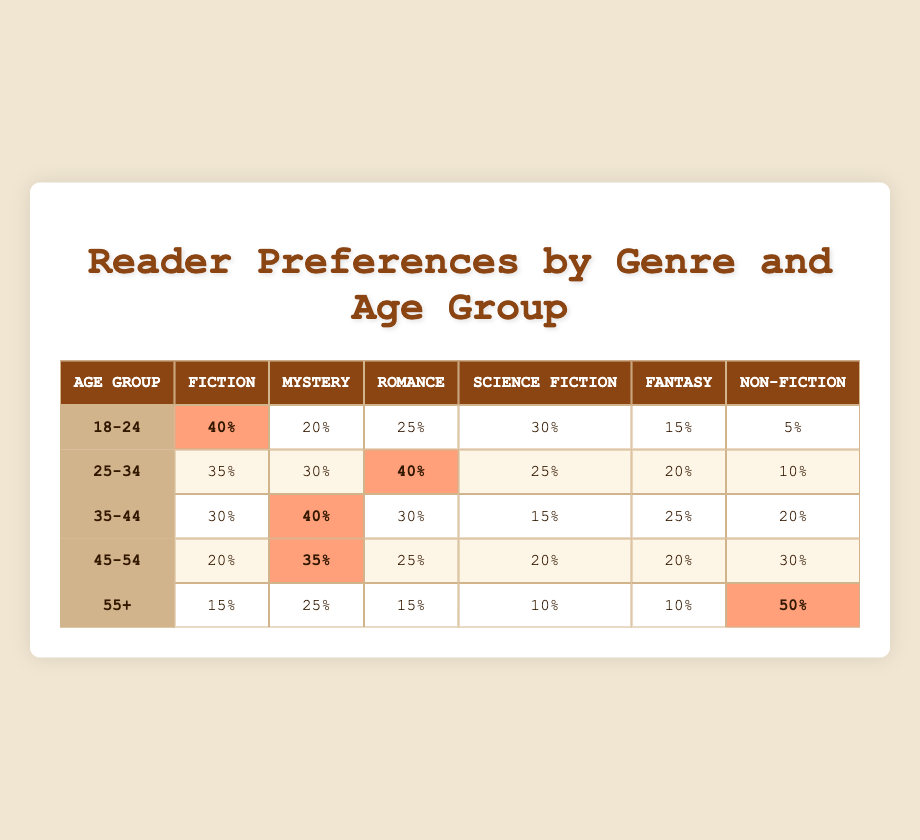What is the percentage of readers aged 45-54 who prefer Mystery? The table shows that for the age group 45-54, the percentage of readers who prefer Mystery is 35%.
Answer: 35% Which age group has the highest percentage of readers for Non-Fiction? Looking at the Non-Fiction column, the age group 55+ has the highest preference at 50%.
Answer: 55+ How many age groups prefer Science Fiction more than 25%? The age groups with preferences above 25% for Science Fiction are 18-24 (30%), 25-34 (25%), and 45-54 (20%). Since only one group 25-34 matches but does not exceed, the count is actually just 2 age groups where 18-24 and 35-44 exceed 25%.
Answer: 2 Which genre is the least preferred by readers aged 18-24? For the age group 18-24, the least preferred genre according to the table is Non-Fiction at 5%.
Answer: Non-Fiction What is the difference in the percentage of Mystery preference between the 25-34 and 35-44 age groups? The Mystery preference for 25-34 is 30%, and for 35-44 it is 40%. Subtracting these gives a difference of 10% (40% - 30% = 10%).
Answer: 10% True or False: More readers aged 55+ prefer Fiction than Romance. The percentages for 55+ show Fiction at 15% and Romance at 15%. Since they are equal, the statement is false.
Answer: False Which genre has consistently lower percentages among older age groups (45-54 and 55+)? By comparing the percentages for both groups, we see that Science Fiction has 20% for 45-54 and 10% for 55+, indicating it has consistently lower percentages among them.
Answer: Science Fiction In total, how many readers aged 35-44 prefer Romance and Fantasy combined? The percentage of readers aged 35-44 who prefer Romance is 30% and Fantasy is 25%. Summing these gives 30% + 25% = 55%.
Answer: 55% Which age group shows a preference for Fiction lower than 20%? The only age group where Fiction preference is lower than 20% is the 55+ group, which has 15% for Fiction.
Answer: 55+ 